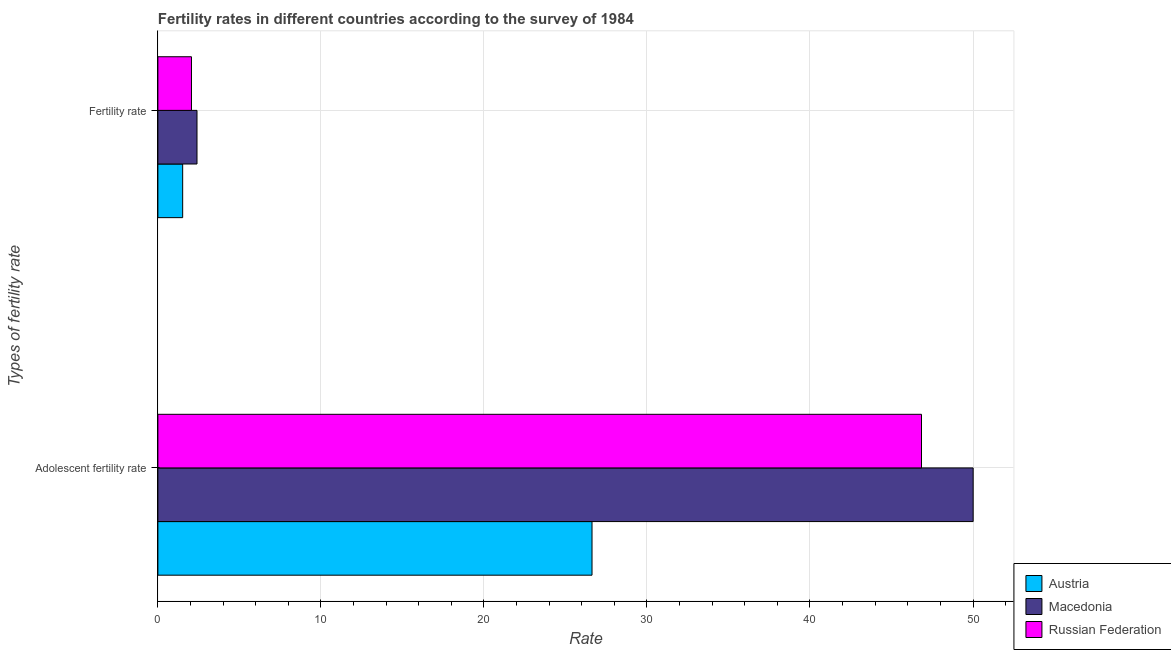How many different coloured bars are there?
Your answer should be compact. 3. How many groups of bars are there?
Your response must be concise. 2. Are the number of bars per tick equal to the number of legend labels?
Make the answer very short. Yes. What is the label of the 2nd group of bars from the top?
Your answer should be very brief. Adolescent fertility rate. What is the fertility rate in Macedonia?
Keep it short and to the point. 2.4. Across all countries, what is the maximum adolescent fertility rate?
Provide a short and direct response. 50.01. Across all countries, what is the minimum fertility rate?
Offer a terse response. 1.52. In which country was the fertility rate maximum?
Give a very brief answer. Macedonia. In which country was the fertility rate minimum?
Ensure brevity in your answer.  Austria. What is the total adolescent fertility rate in the graph?
Provide a short and direct response. 123.48. What is the difference between the fertility rate in Austria and that in Macedonia?
Make the answer very short. -0.88. What is the difference between the fertility rate in Macedonia and the adolescent fertility rate in Austria?
Your answer should be very brief. -24.23. What is the average adolescent fertility rate per country?
Make the answer very short. 41.16. What is the difference between the adolescent fertility rate and fertility rate in Russian Federation?
Your response must be concise. 44.78. In how many countries, is the adolescent fertility rate greater than 30 ?
Ensure brevity in your answer.  2. What is the ratio of the adolescent fertility rate in Macedonia to that in Russian Federation?
Provide a short and direct response. 1.07. In how many countries, is the fertility rate greater than the average fertility rate taken over all countries?
Give a very brief answer. 2. What does the 3rd bar from the bottom in Fertility rate represents?
Give a very brief answer. Russian Federation. Are all the bars in the graph horizontal?
Your answer should be very brief. Yes. How many countries are there in the graph?
Provide a short and direct response. 3. Are the values on the major ticks of X-axis written in scientific E-notation?
Provide a short and direct response. No. Does the graph contain any zero values?
Keep it short and to the point. No. Does the graph contain grids?
Your response must be concise. Yes. How many legend labels are there?
Your answer should be very brief. 3. What is the title of the graph?
Your answer should be very brief. Fertility rates in different countries according to the survey of 1984. What is the label or title of the X-axis?
Your answer should be very brief. Rate. What is the label or title of the Y-axis?
Ensure brevity in your answer.  Types of fertility rate. What is the Rate of Austria in Adolescent fertility rate?
Your response must be concise. 26.63. What is the Rate in Macedonia in Adolescent fertility rate?
Give a very brief answer. 50.01. What is the Rate of Russian Federation in Adolescent fertility rate?
Your response must be concise. 46.84. What is the Rate of Austria in Fertility rate?
Offer a terse response. 1.52. What is the Rate in Macedonia in Fertility rate?
Ensure brevity in your answer.  2.4. What is the Rate of Russian Federation in Fertility rate?
Give a very brief answer. 2.06. Across all Types of fertility rate, what is the maximum Rate of Austria?
Your answer should be very brief. 26.63. Across all Types of fertility rate, what is the maximum Rate of Macedonia?
Your response must be concise. 50.01. Across all Types of fertility rate, what is the maximum Rate in Russian Federation?
Your response must be concise. 46.84. Across all Types of fertility rate, what is the minimum Rate of Austria?
Offer a terse response. 1.52. Across all Types of fertility rate, what is the minimum Rate of Macedonia?
Ensure brevity in your answer.  2.4. Across all Types of fertility rate, what is the minimum Rate in Russian Federation?
Give a very brief answer. 2.06. What is the total Rate in Austria in the graph?
Offer a very short reply. 28.15. What is the total Rate of Macedonia in the graph?
Provide a short and direct response. 52.41. What is the total Rate of Russian Federation in the graph?
Provide a short and direct response. 48.9. What is the difference between the Rate of Austria in Adolescent fertility rate and that in Fertility rate?
Keep it short and to the point. 25.11. What is the difference between the Rate in Macedonia in Adolescent fertility rate and that in Fertility rate?
Ensure brevity in your answer.  47.61. What is the difference between the Rate in Russian Federation in Adolescent fertility rate and that in Fertility rate?
Keep it short and to the point. 44.78. What is the difference between the Rate of Austria in Adolescent fertility rate and the Rate of Macedonia in Fertility rate?
Offer a very short reply. 24.23. What is the difference between the Rate of Austria in Adolescent fertility rate and the Rate of Russian Federation in Fertility rate?
Give a very brief answer. 24.57. What is the difference between the Rate of Macedonia in Adolescent fertility rate and the Rate of Russian Federation in Fertility rate?
Offer a very short reply. 47.95. What is the average Rate of Austria per Types of fertility rate?
Offer a terse response. 14.07. What is the average Rate in Macedonia per Types of fertility rate?
Give a very brief answer. 26.2. What is the average Rate of Russian Federation per Types of fertility rate?
Ensure brevity in your answer.  24.45. What is the difference between the Rate in Austria and Rate in Macedonia in Adolescent fertility rate?
Your response must be concise. -23.38. What is the difference between the Rate in Austria and Rate in Russian Federation in Adolescent fertility rate?
Your response must be concise. -20.21. What is the difference between the Rate in Macedonia and Rate in Russian Federation in Adolescent fertility rate?
Offer a terse response. 3.17. What is the difference between the Rate in Austria and Rate in Macedonia in Fertility rate?
Your response must be concise. -0.88. What is the difference between the Rate of Austria and Rate of Russian Federation in Fertility rate?
Offer a terse response. -0.54. What is the difference between the Rate in Macedonia and Rate in Russian Federation in Fertility rate?
Ensure brevity in your answer.  0.34. What is the ratio of the Rate in Austria in Adolescent fertility rate to that in Fertility rate?
Provide a succinct answer. 17.52. What is the ratio of the Rate in Macedonia in Adolescent fertility rate to that in Fertility rate?
Provide a short and direct response. 20.85. What is the ratio of the Rate in Russian Federation in Adolescent fertility rate to that in Fertility rate?
Offer a very short reply. 22.74. What is the difference between the highest and the second highest Rate of Austria?
Keep it short and to the point. 25.11. What is the difference between the highest and the second highest Rate of Macedonia?
Offer a very short reply. 47.61. What is the difference between the highest and the second highest Rate in Russian Federation?
Your answer should be very brief. 44.78. What is the difference between the highest and the lowest Rate of Austria?
Offer a terse response. 25.11. What is the difference between the highest and the lowest Rate in Macedonia?
Ensure brevity in your answer.  47.61. What is the difference between the highest and the lowest Rate in Russian Federation?
Give a very brief answer. 44.78. 